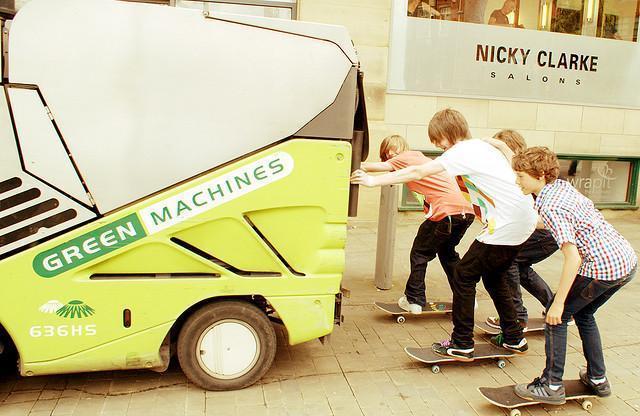How many people are there?
Give a very brief answer. 4. How many trucks are there?
Give a very brief answer. 1. How many giraffes are in the photo?
Give a very brief answer. 0. 